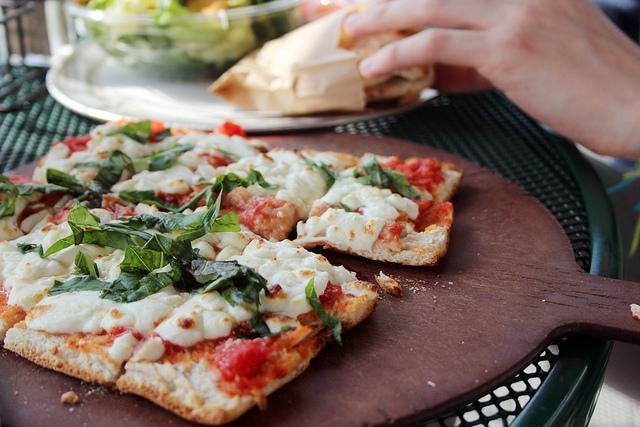Why is the pizza cut into small pieces? easier eating 